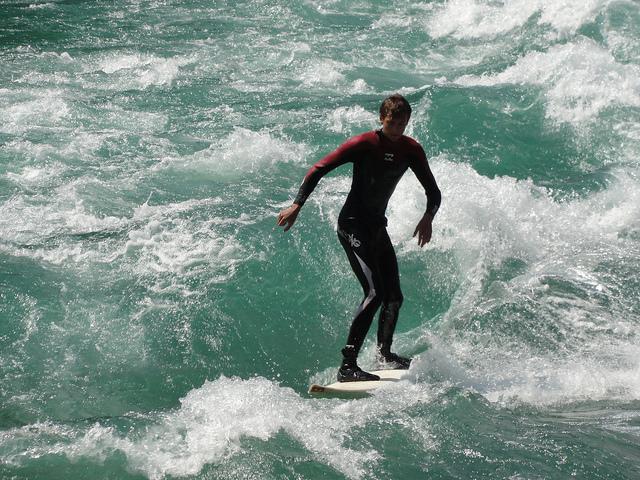What color is the person's suit?
Short answer required. Red and black. Is the water dirty or clean?
Short answer required. Clean. What is the person doing?
Short answer required. Surfing. Is the surfer being towed?
Short answer required. No. Is the person wearing a wetsuit?
Keep it brief. Yes. Is the man wearing shorts?
Answer briefly. No. How many surfers in the water?
Concise answer only. 1. 